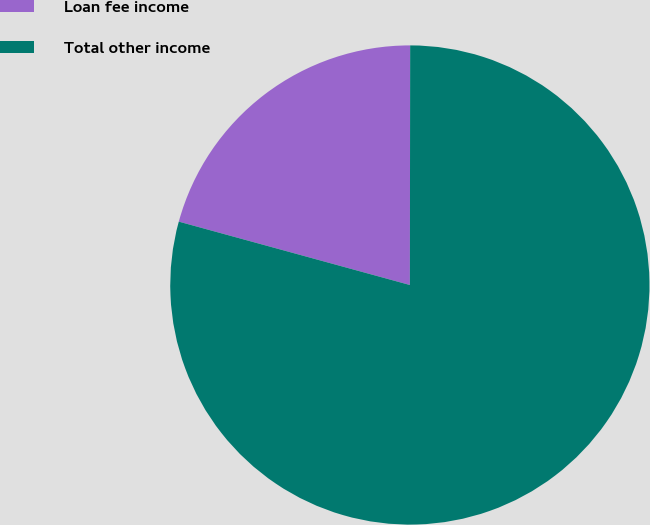Convert chart. <chart><loc_0><loc_0><loc_500><loc_500><pie_chart><fcel>Loan fee income<fcel>Total other income<nl><fcel>20.76%<fcel>79.24%<nl></chart> 